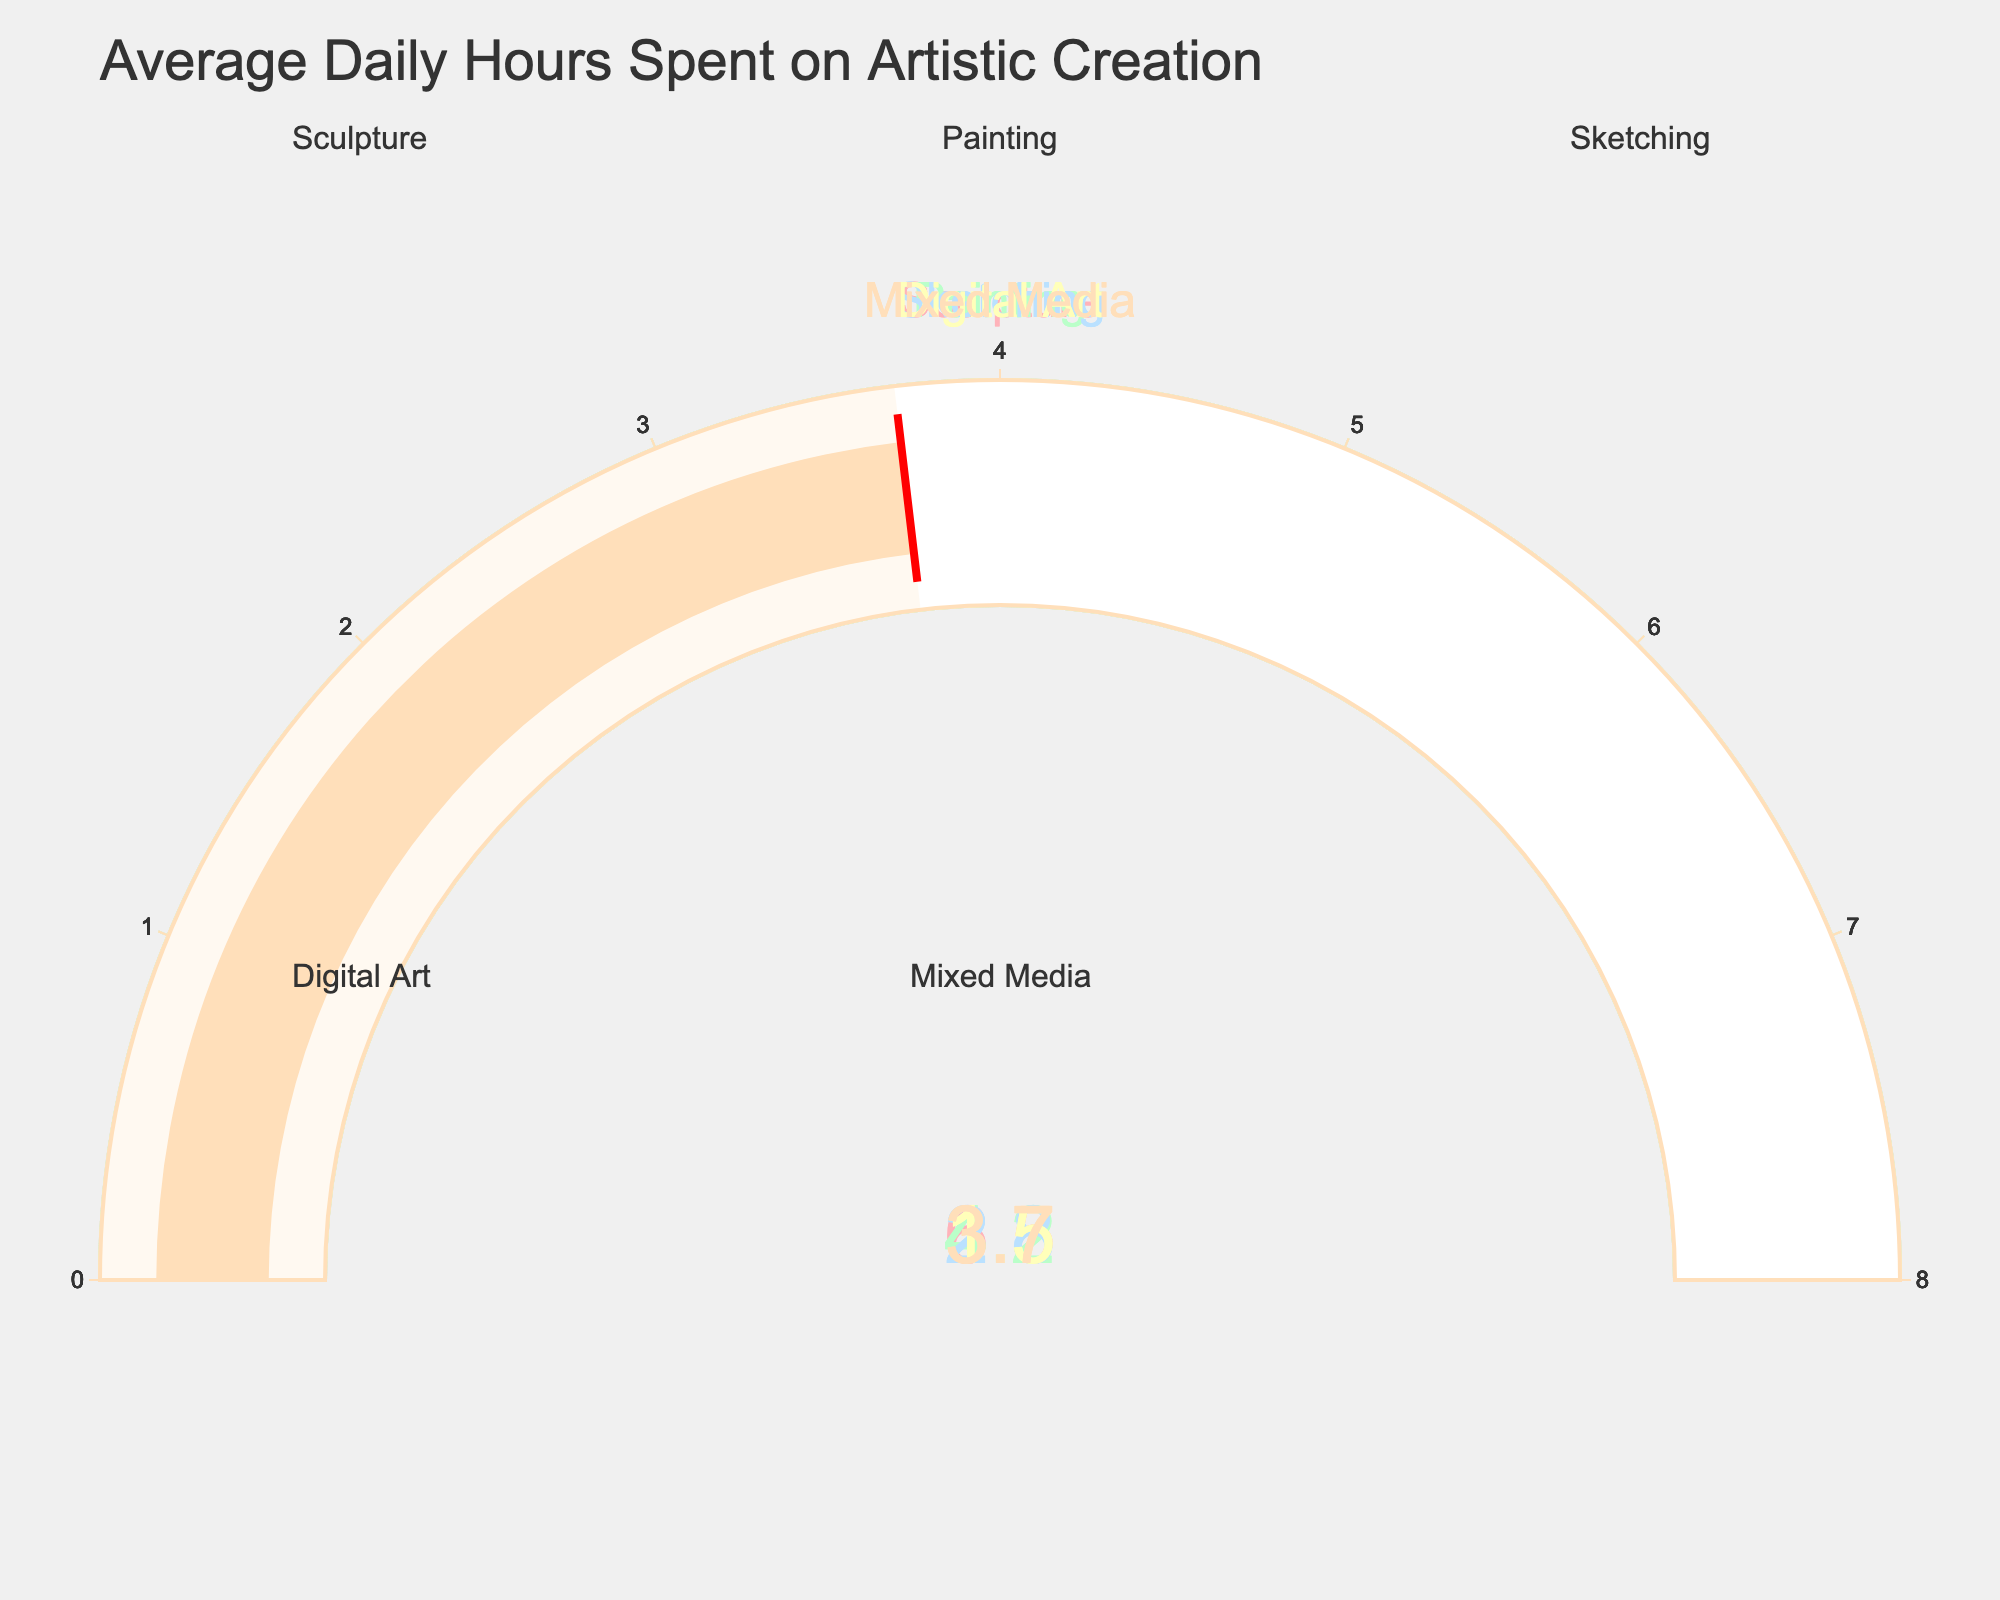What is the title of the figure? The title is located at the top of the figure, usually in larger or bold font, summarizing the graphical content. Here, it reads "Average Daily Hours Spent on Artistic Creation".
Answer: Average Daily Hours Spent on Artistic Creation Which art category has the highest average daily hours spent? Observing the gauge charts, we identify that "Sculpture" has the highest value with 6.5 hours.
Answer: Sculpture What art category has a gauge chart displaying 4.2 hours? By identifying the gauge chart with the value 4.2, we can see that it corresponds to "Painting".
Answer: Painting How many categories are represented in the figure? Counting each of the gauge charts, we observe five distinct categories.
Answer: 5 What are the displayed hours for Digital Art? The gauge chart for "Digital Art" shows a value of 1.5 hours.
Answer: 1.5 What is the combined average daily hours spent on Sketching and Mixed Media? Adding the hours for Sketching (2.8) and Mixed Media (3.7), we get 2.8 + 3.7 = 6.5 hours.
Answer: 6.5 Which art category has the lowest average daily hours spent? Among all gauge charts, "Digital Art" has the lowest value with 1.5 hours.
Answer: Digital Art What is the difference in hours between Sculpture and Sketching? Subtracting Sketching hours (2.8) from Sculpture hours (6.5), we get 6.5 - 2.8 = 3.7 hours.
Answer: 3.7 Among Sculpture, Painting, and Digital Art, which category has the median value of average daily hours? The values for Sculpture, Painting, and Digital Art are 6.5, 4.2, and 1.5 respectively. Sorting these gives 1.5, 4.2, 6.5; hence, Painting, with 4.2 hours, is the median.
Answer: Painting 